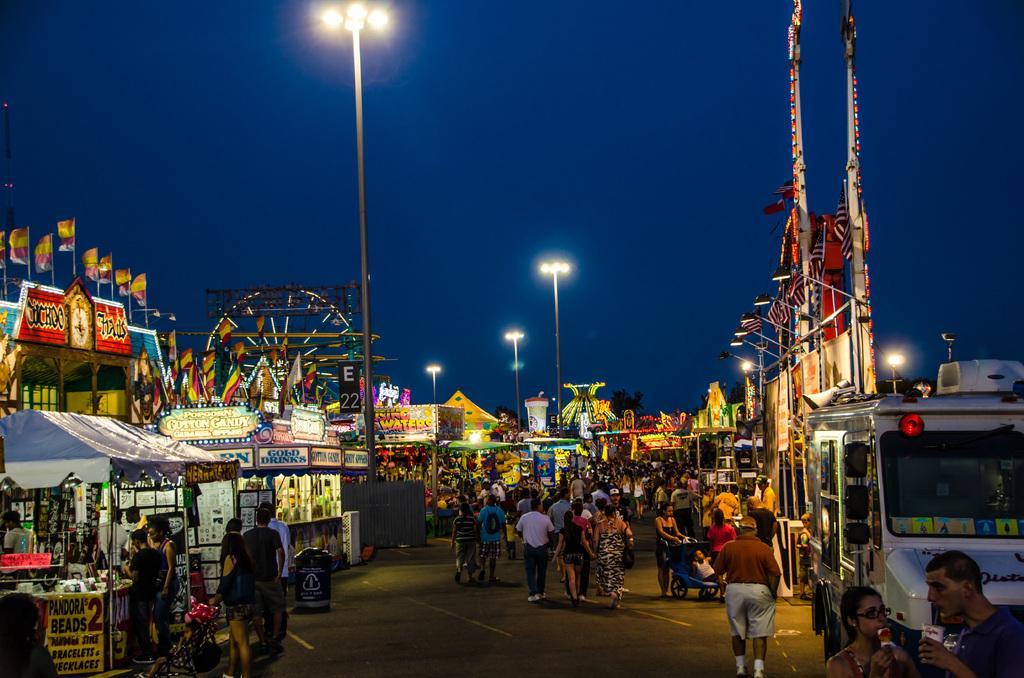In one or two sentences, can you explain what this image depicts? This is a street view. there are many people. On the left side there are many shops with flags, name boards and banners. There are light poles. In the back there is a giant wheel. On the right side there is a vehicle. There is a board with flags and lights. In the background there are tents and sky. 